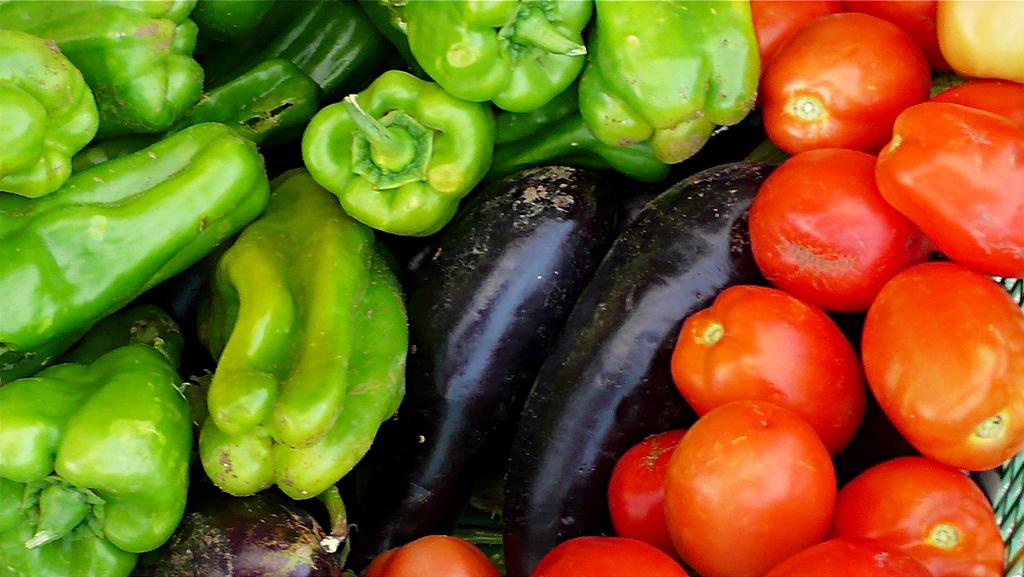What type of food is present in the image? There are vegetables in the image. Can you name some specific vegetables that can be seen? The vegetables include tomatoes, capsicums, and aubergines. What type of fang can be seen in the image? There is no fang present in the image; it features vegetables, including tomatoes, capsicums, and aubergines. Where is the drawer located in the image? There is no drawer present in the image. 